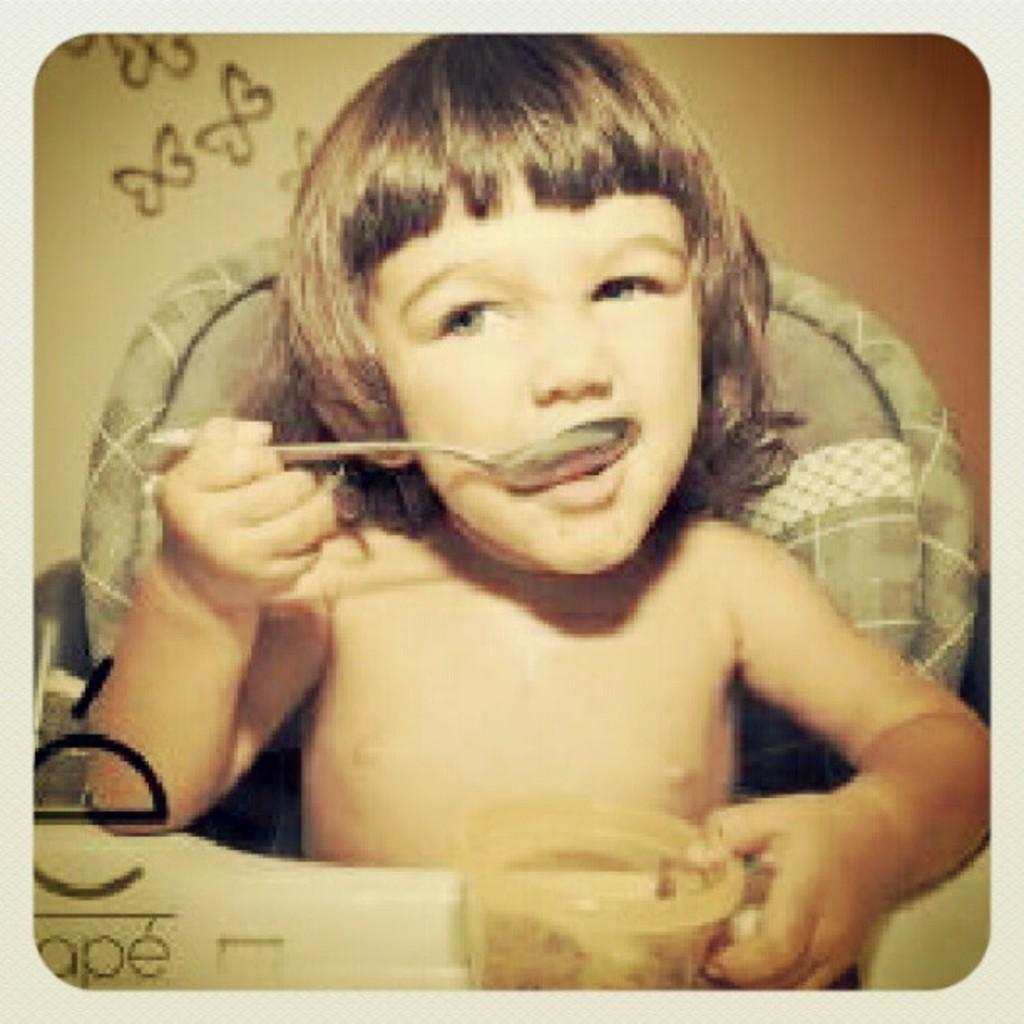Who is the main subject in the image? There is a girl in the image. What is the girl doing in the image? The girl is sitting in front of a table and eating something with a spoon. What can be seen in the background of the image? There are drawings on the wall in the background. Can you see a river flowing behind the girl in the image? No, there is no river visible in the image. 